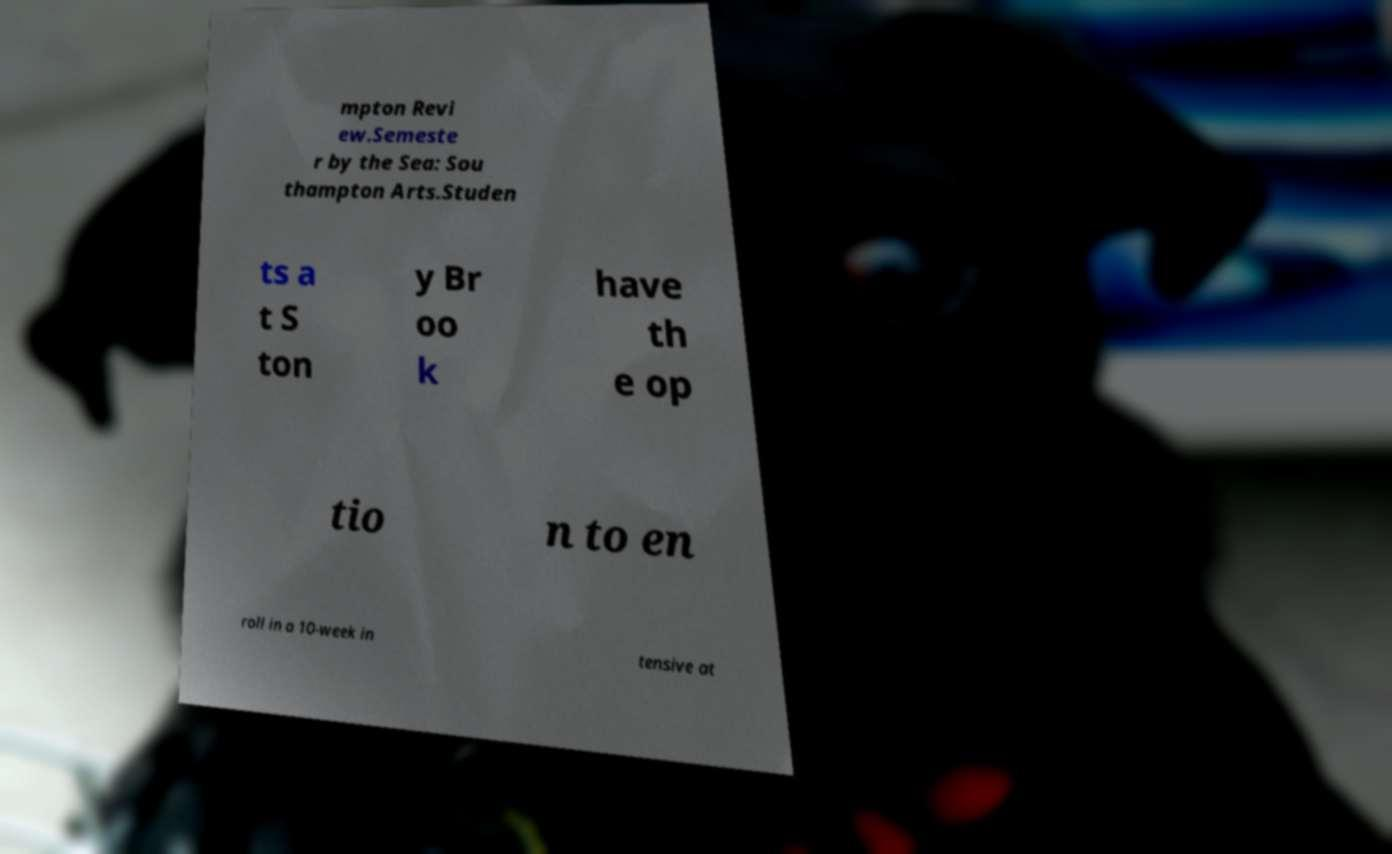Can you read and provide the text displayed in the image?This photo seems to have some interesting text. Can you extract and type it out for me? mpton Revi ew.Semeste r by the Sea: Sou thampton Arts.Studen ts a t S ton y Br oo k have th e op tio n to en roll in a 10-week in tensive at 